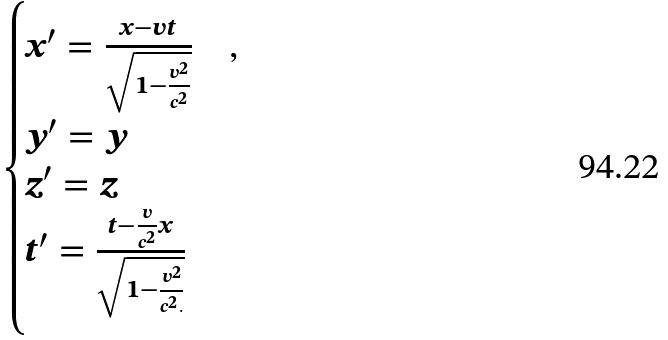Convert formula to latex. <formula><loc_0><loc_0><loc_500><loc_500>\begin{cases} x ^ { \prime } = \frac { x - { v } t } { \sqrt { 1 - \frac { v ^ { 2 } } { c ^ { 2 } } } } & , \\ y ^ { \prime } = y & \\ z ^ { \prime } = z & \\ t ^ { \prime } = \frac { t - \frac { v } { c ^ { 2 } } x } { \sqrt { 1 - \frac { v ^ { 2 } } { c ^ { 2 } . } } } & \end{cases}</formula> 